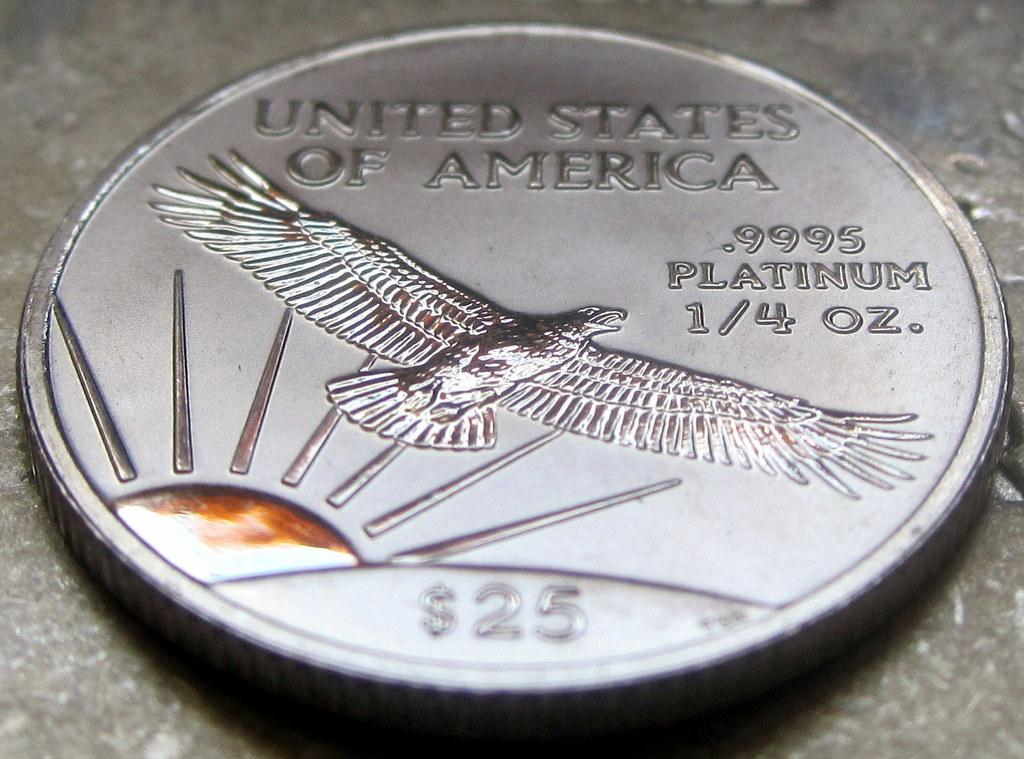Provide a one-sentence caption for the provided image. A coin made in the United States is made up of platinum. 